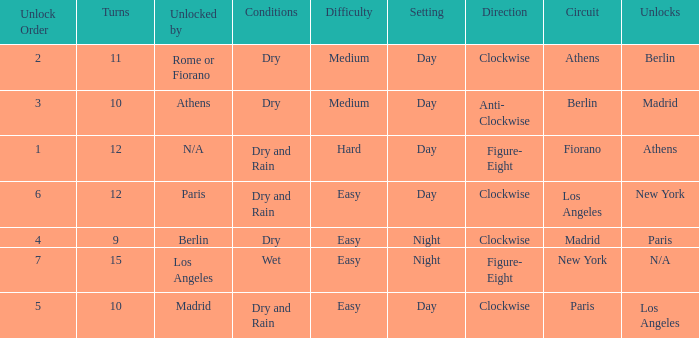What is the difficulty of the athens circuit? Medium. 